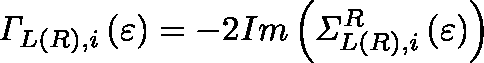Convert formula to latex. <formula><loc_0><loc_0><loc_500><loc_500>{ \Gamma } _ { L ( R ) , i } \left ( \varepsilon \right ) = - 2 I m \left ( { \Sigma } _ { L ( R ) , i } ^ { R } \left ( \varepsilon \right ) \right )</formula> 